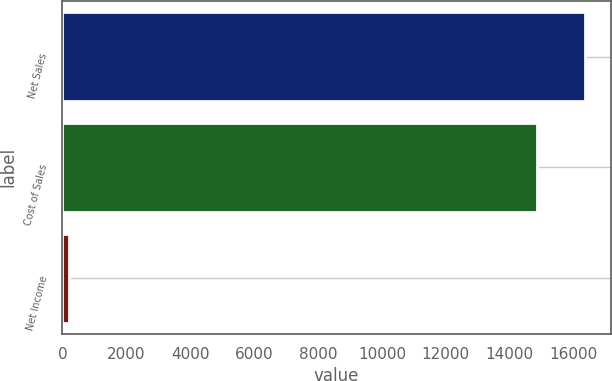<chart> <loc_0><loc_0><loc_500><loc_500><bar_chart><fcel>Net Sales<fcel>Cost of Sales<fcel>Net Income<nl><fcel>16348<fcel>14849<fcel>199<nl></chart> 